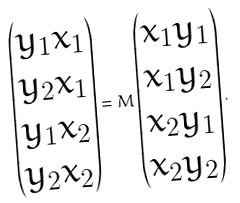Convert formula to latex. <formula><loc_0><loc_0><loc_500><loc_500>\begin{pmatrix} y _ { 1 } x _ { 1 } \\ y _ { 2 } x _ { 1 } \\ y _ { 1 } x _ { 2 } \\ y _ { 2 } x _ { 2 } \end{pmatrix} = M \begin{pmatrix} x _ { 1 } y _ { 1 } \\ x _ { 1 } y _ { 2 } \\ x _ { 2 } y _ { 1 } \\ x _ { 2 } y _ { 2 } \end{pmatrix} .</formula> 